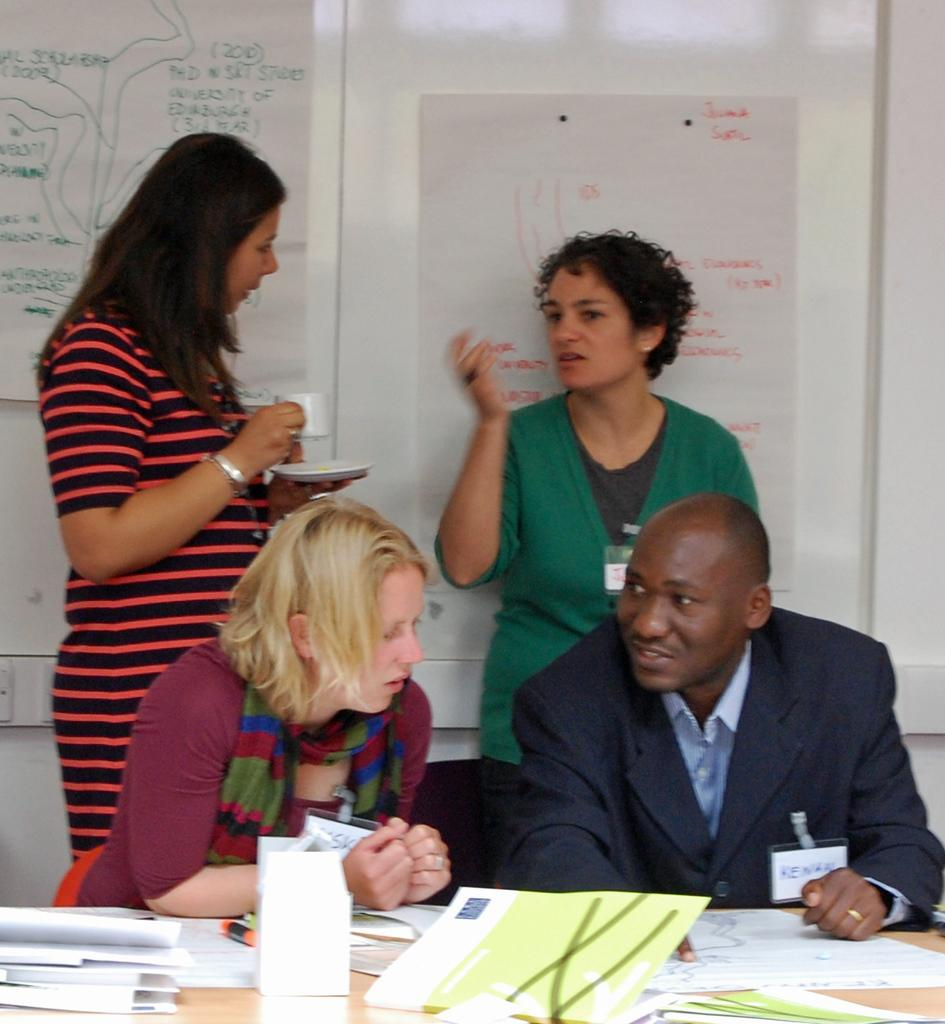What is the man in the image doing? The man is sitting in the image. Who else is present in the image besides the man? There is a woman and two women standing in the image. What are the two standing women doing? The two standing women are talking. What can be seen in the image that might be related to information or data? There is a chart in the image. What type of arch can be seen in the image? There is no arch present in the image. Is there a dock visible in the image? No, there is no dock present in the image. 